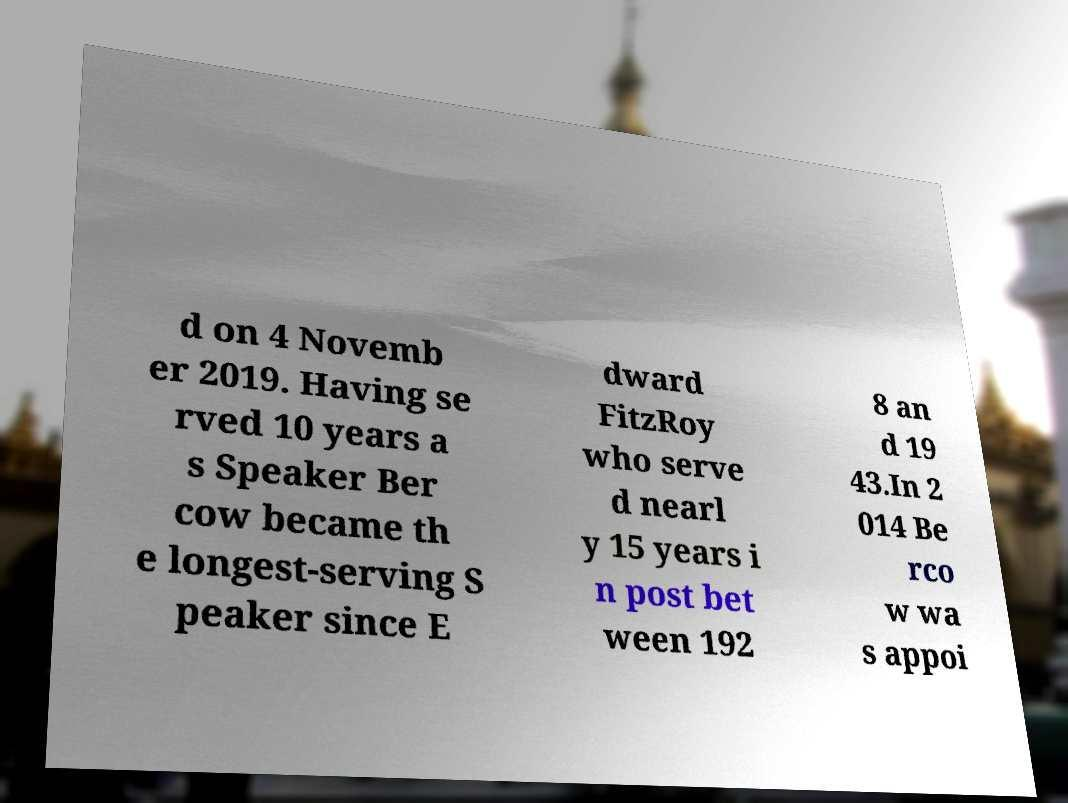Please identify and transcribe the text found in this image. d on 4 Novemb er 2019. Having se rved 10 years a s Speaker Ber cow became th e longest-serving S peaker since E dward FitzRoy who serve d nearl y 15 years i n post bet ween 192 8 an d 19 43.In 2 014 Be rco w wa s appoi 